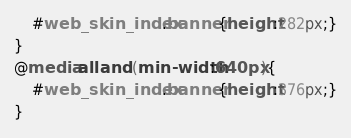Convert code to text. <code><loc_0><loc_0><loc_500><loc_500><_CSS_>	#web_skin_index .banner{height:282px;}
}
@media all and (min-width:640px){
	#web_skin_index .banner{height:376px;}
}</code> 